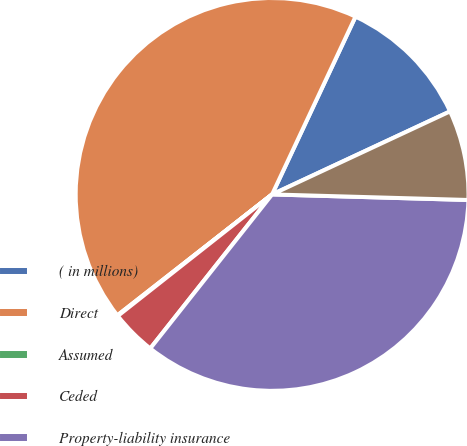Convert chart to OTSL. <chart><loc_0><loc_0><loc_500><loc_500><pie_chart><fcel>( in millions)<fcel>Direct<fcel>Assumed<fcel>Ceded<fcel>Property-liability insurance<fcel>Life and annuity premiums and<nl><fcel>11.07%<fcel>42.54%<fcel>0.06%<fcel>3.73%<fcel>35.2%<fcel>7.4%<nl></chart> 